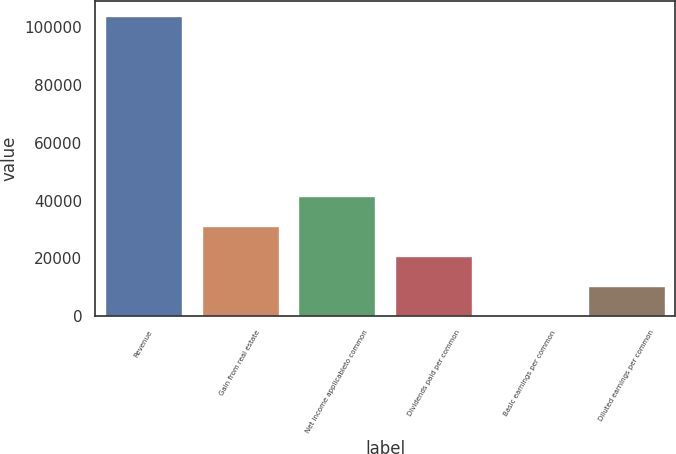Convert chart to OTSL. <chart><loc_0><loc_0><loc_500><loc_500><bar_chart><fcel>Revenue<fcel>Gain from real estate<fcel>Net income applicableto common<fcel>Dividends paid per common<fcel>Basic earnings per common<fcel>Diluted earnings per common<nl><fcel>103827<fcel>31148.3<fcel>41531<fcel>20765.6<fcel>0.28<fcel>10383<nl></chart> 